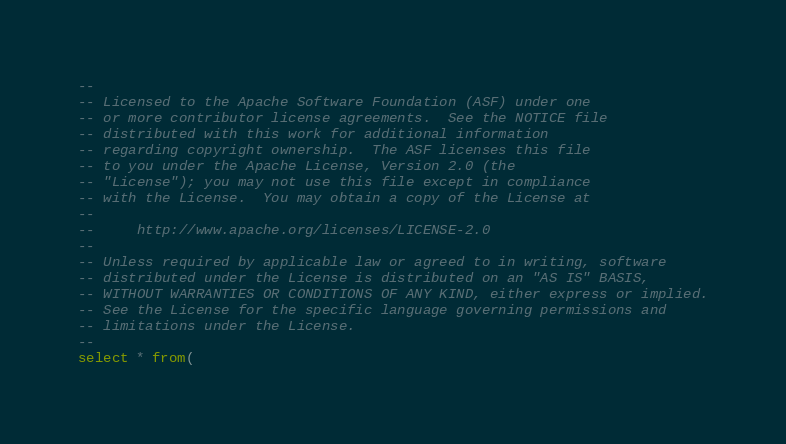<code> <loc_0><loc_0><loc_500><loc_500><_SQL_>--
-- Licensed to the Apache Software Foundation (ASF) under one
-- or more contributor license agreements.  See the NOTICE file
-- distributed with this work for additional information
-- regarding copyright ownership.  The ASF licenses this file
-- to you under the Apache License, Version 2.0 (the
-- "License"); you may not use this file except in compliance
-- with the License.  You may obtain a copy of the License at
--
--     http://www.apache.org/licenses/LICENSE-2.0
--
-- Unless required by applicable law or agreed to in writing, software
-- distributed under the License is distributed on an "AS IS" BASIS,
-- WITHOUT WARRANTIES OR CONDITIONS OF ANY KIND, either express or implied.
-- See the License for the specific language governing permissions and
-- limitations under the License.
--
select * from(</code> 